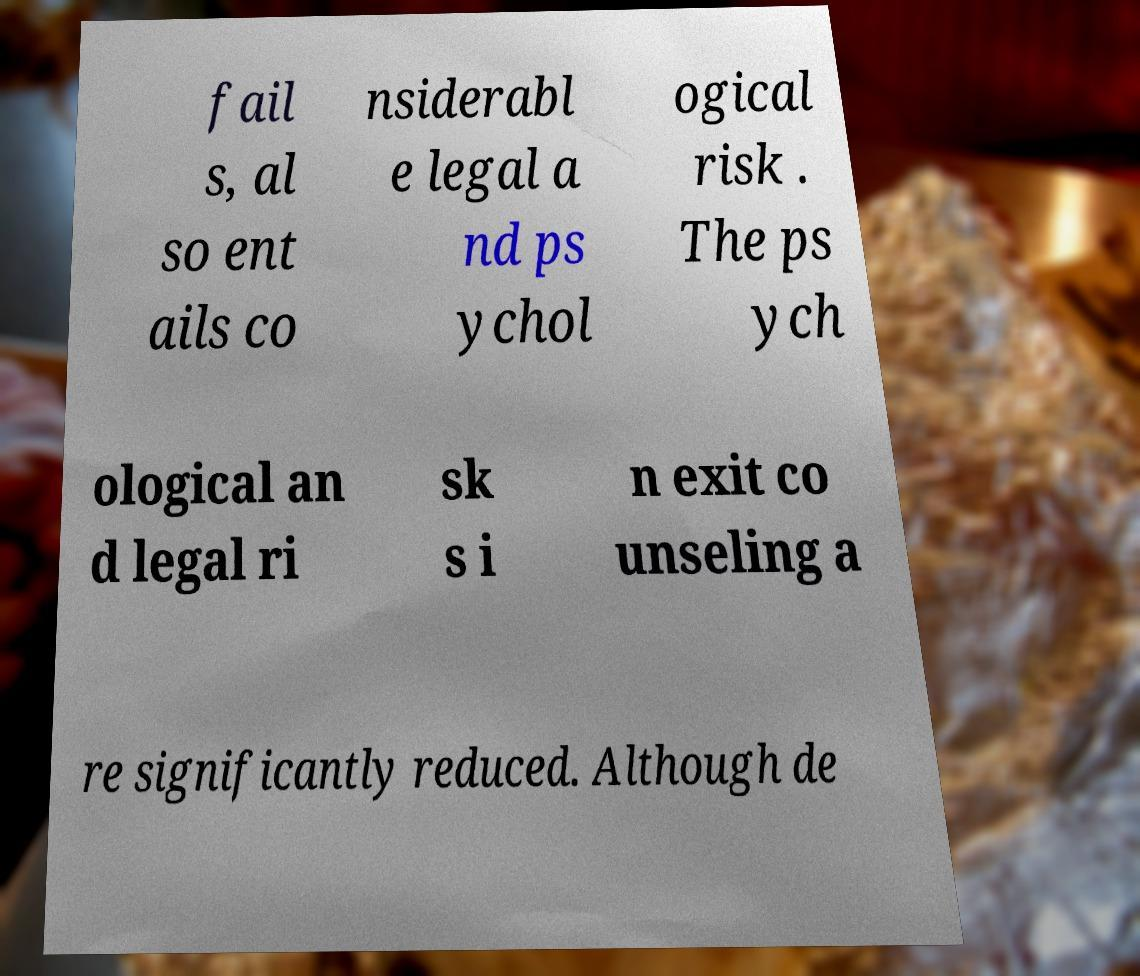Could you assist in decoding the text presented in this image and type it out clearly? fail s, al so ent ails co nsiderabl e legal a nd ps ychol ogical risk . The ps ych ological an d legal ri sk s i n exit co unseling a re significantly reduced. Although de 